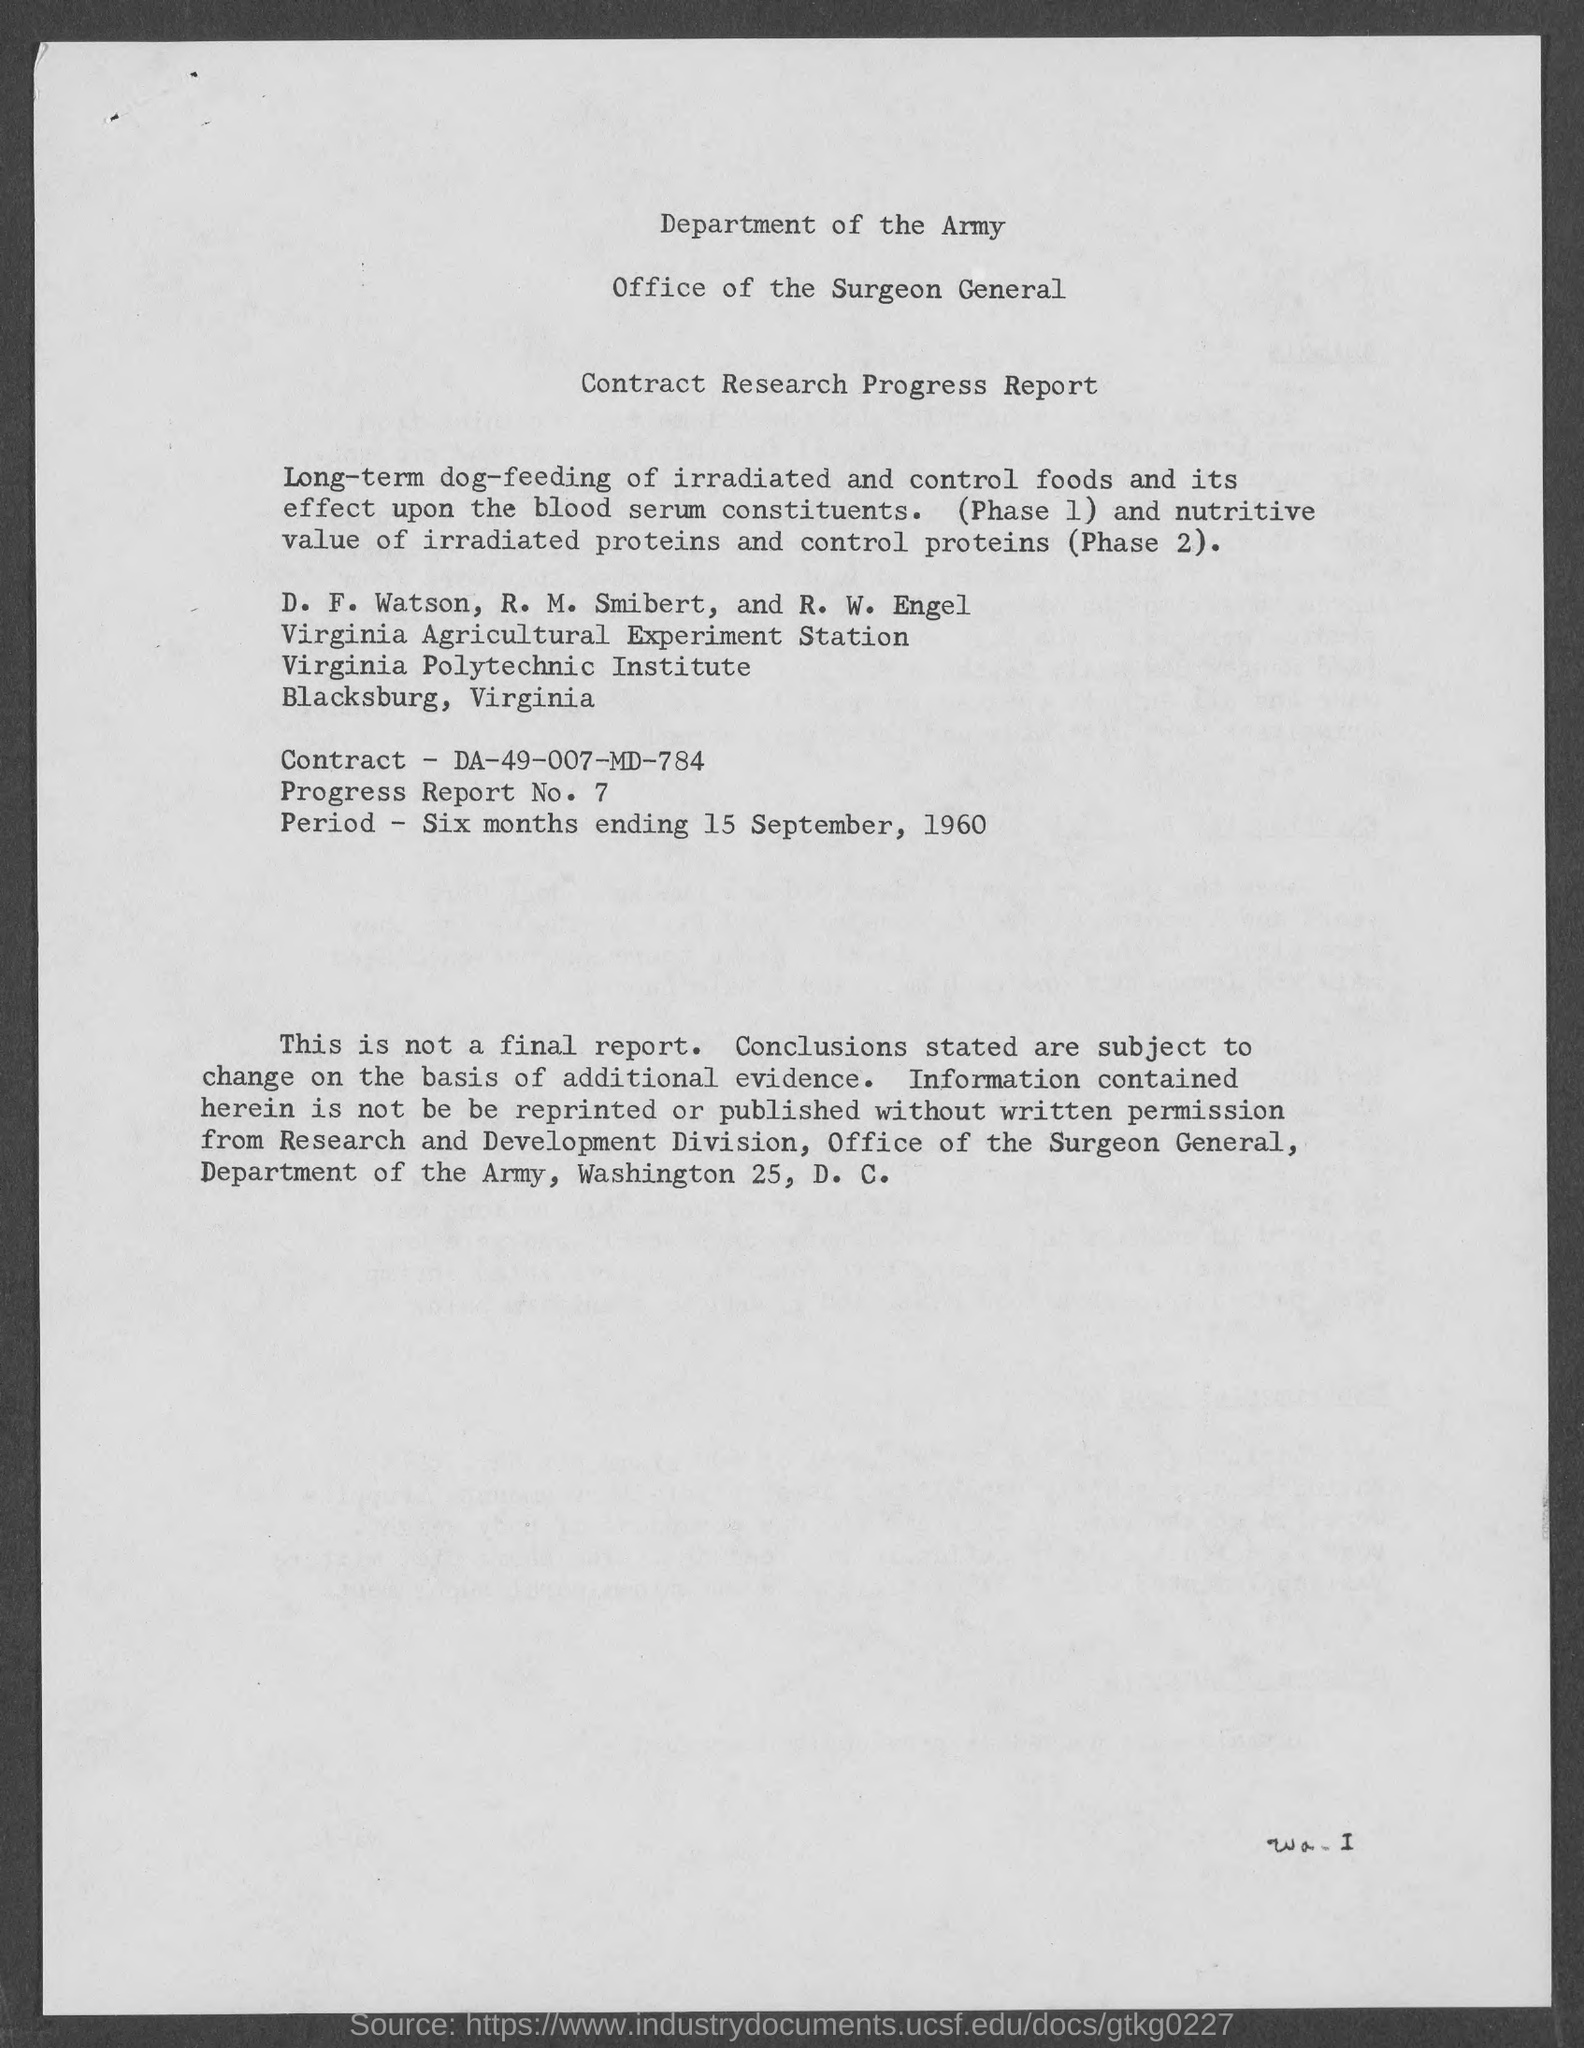Outline some significant characteristics in this image. The document contains a progress report number of 7. The period of the contract mentioned in the document is six months ending on September 15, 1960. The contract number given in the document is DA-49-007-MD-784. 